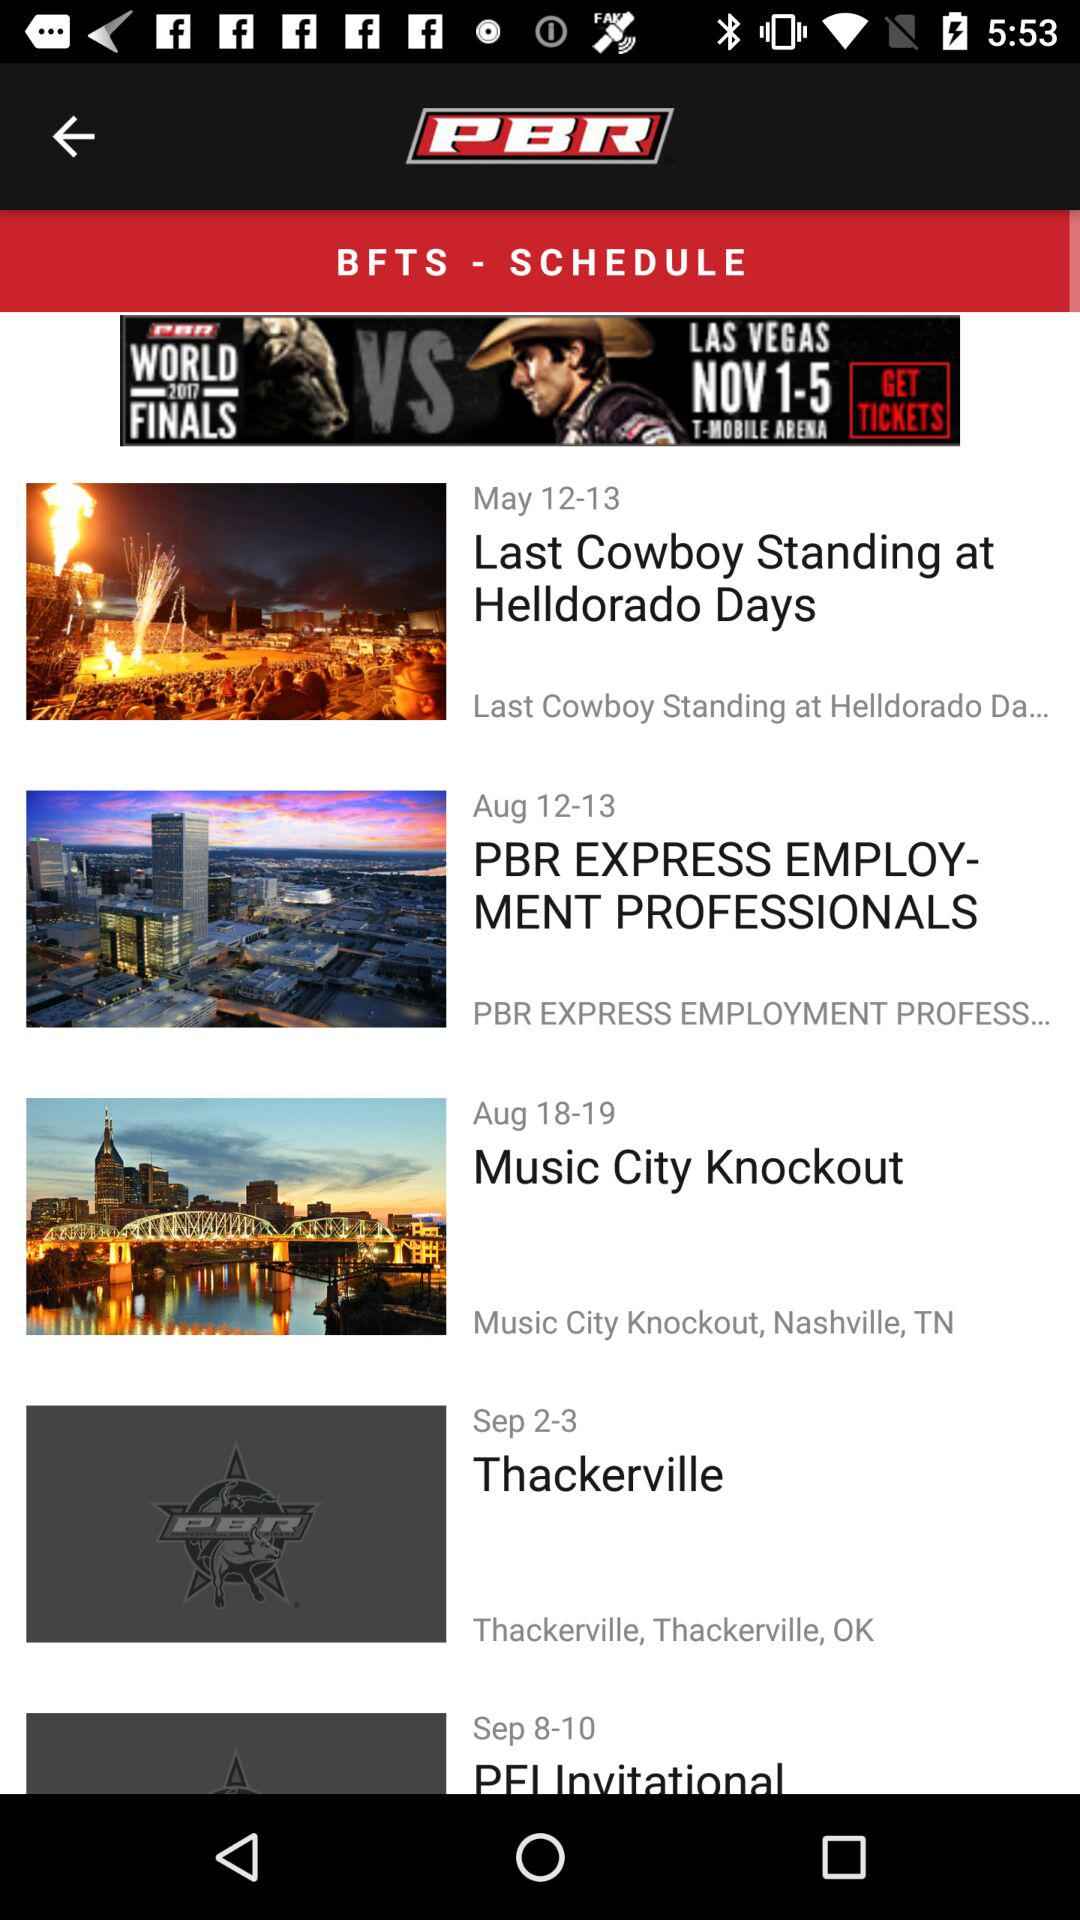How many events are in the month of August?
Answer the question using a single word or phrase. 2 